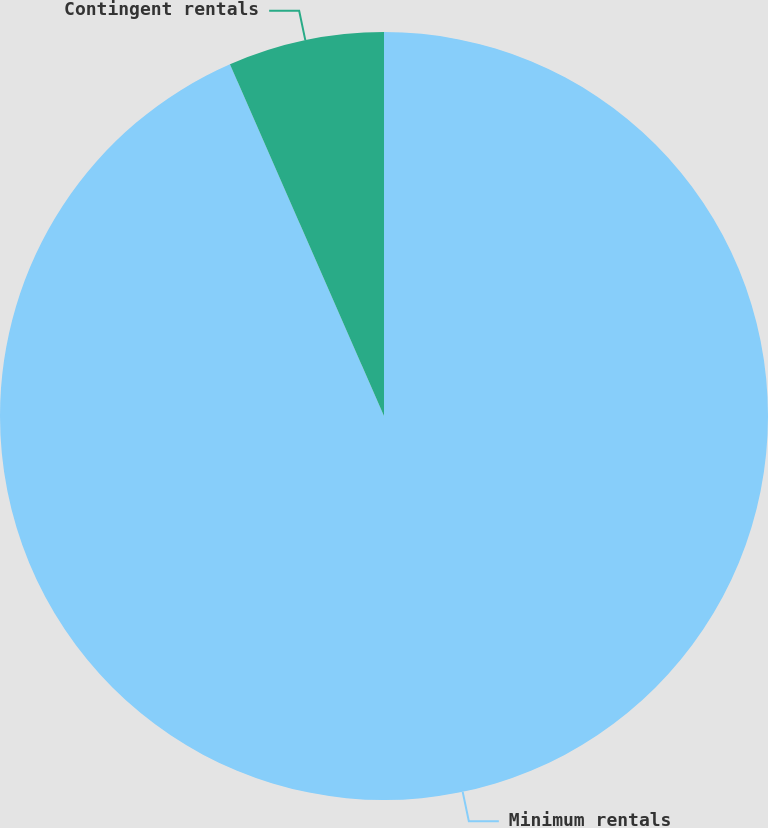Convert chart. <chart><loc_0><loc_0><loc_500><loc_500><pie_chart><fcel>Minimum rentals<fcel>Contingent rentals<nl><fcel>93.43%<fcel>6.57%<nl></chart> 